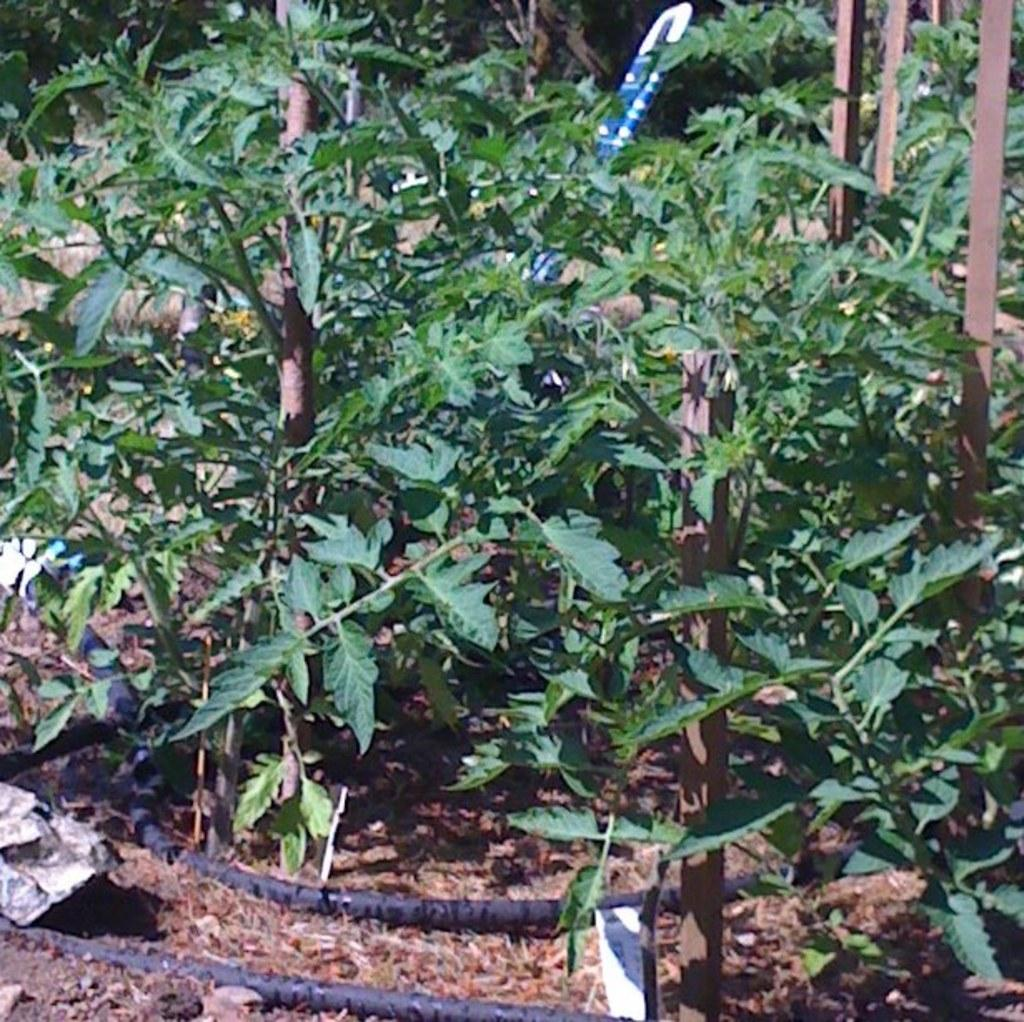What type of living organisms can be seen in the image? Plants can be seen in the image. What objects are on the ground in the image? There are pipes on the ground in the image. What can be seen in the top right of the image? There are poles in the top right of the image. What type of humor can be seen in the image? There is no humor present in the image; it features plants, pipes, and poles. What type of brush is used to maintain the plants in the image? There is no brush visible in the image, and the type of maintenance for the plants is not mentioned. 